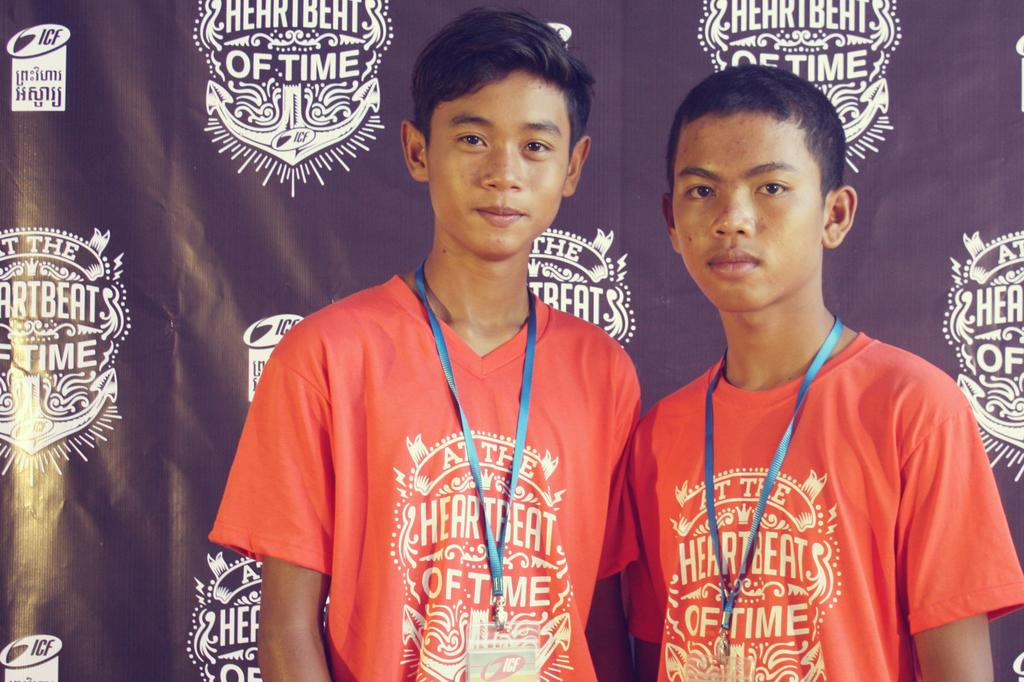<image>
Share a concise interpretation of the image provided. Two kids with a shirt saying at the heartbeat of time 